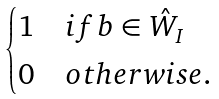Convert formula to latex. <formula><loc_0><loc_0><loc_500><loc_500>\begin{cases} 1 & i f b \in \hat { W } _ { I } \\ 0 & o t h e r w i s e . \end{cases}</formula> 